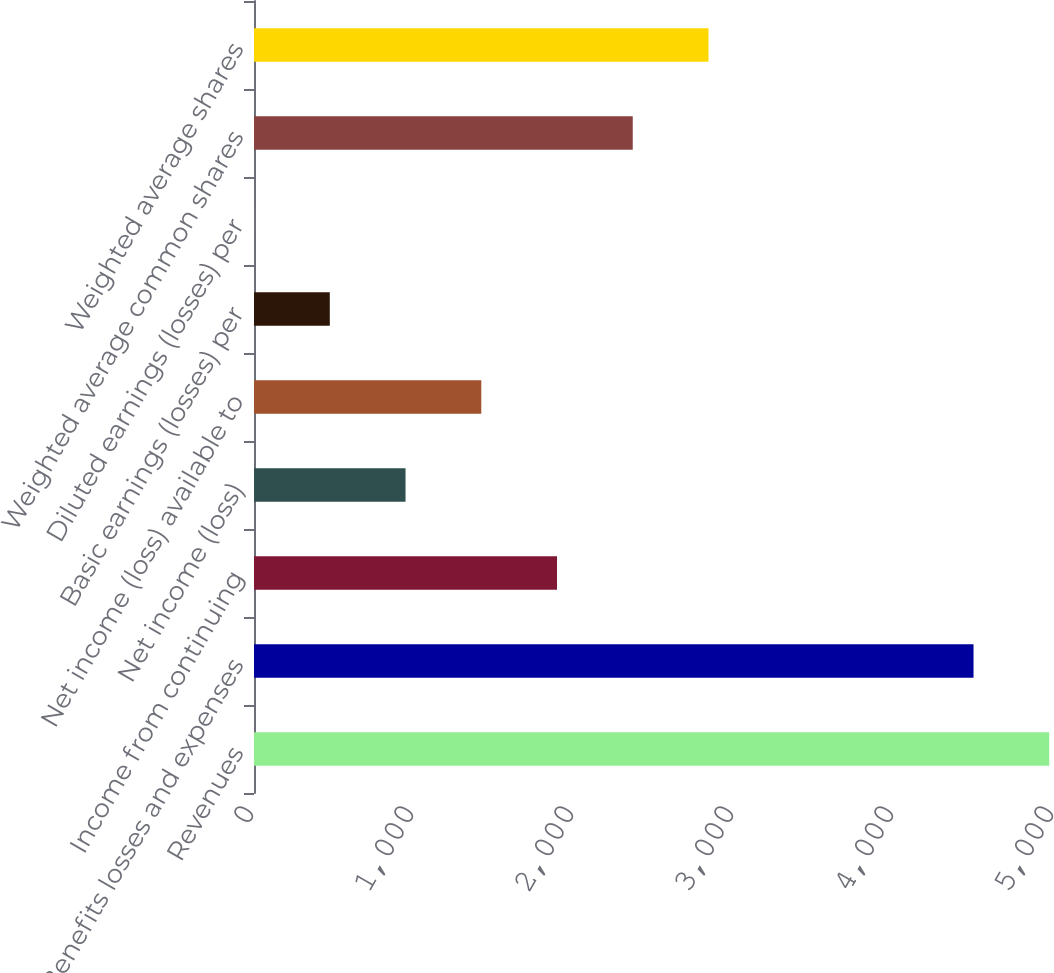<chart> <loc_0><loc_0><loc_500><loc_500><bar_chart><fcel>Revenues<fcel>Benefits losses and expenses<fcel>Income from continuing<fcel>Net income (loss)<fcel>Net income (loss) available to<fcel>Basic earnings (losses) per<fcel>Diluted earnings (losses) per<fcel>Weighted average common shares<fcel>Weighted average shares<nl><fcel>4970.36<fcel>4497<fcel>1893.83<fcel>947.11<fcel>1420.47<fcel>473.75<fcel>0.39<fcel>2367.19<fcel>2840.55<nl></chart> 